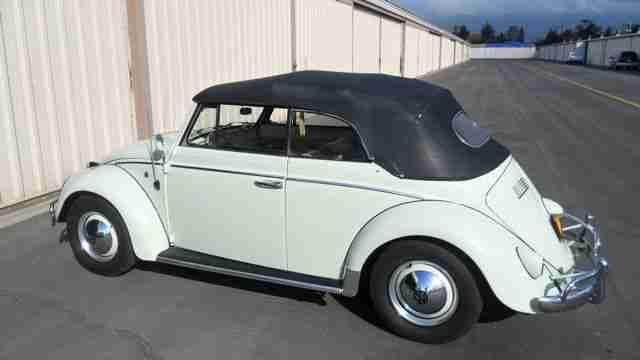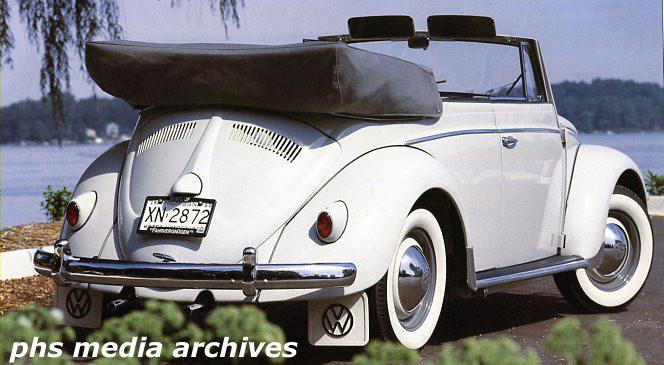The first image is the image on the left, the second image is the image on the right. Given the left and right images, does the statement "An image shows a non-white rear-facing convertible that is not parked on grass." hold true? Answer yes or no. No. The first image is the image on the left, the second image is the image on the right. Given the left and right images, does the statement "One of the cars is parked entirely in grass." hold true? Answer yes or no. No. 